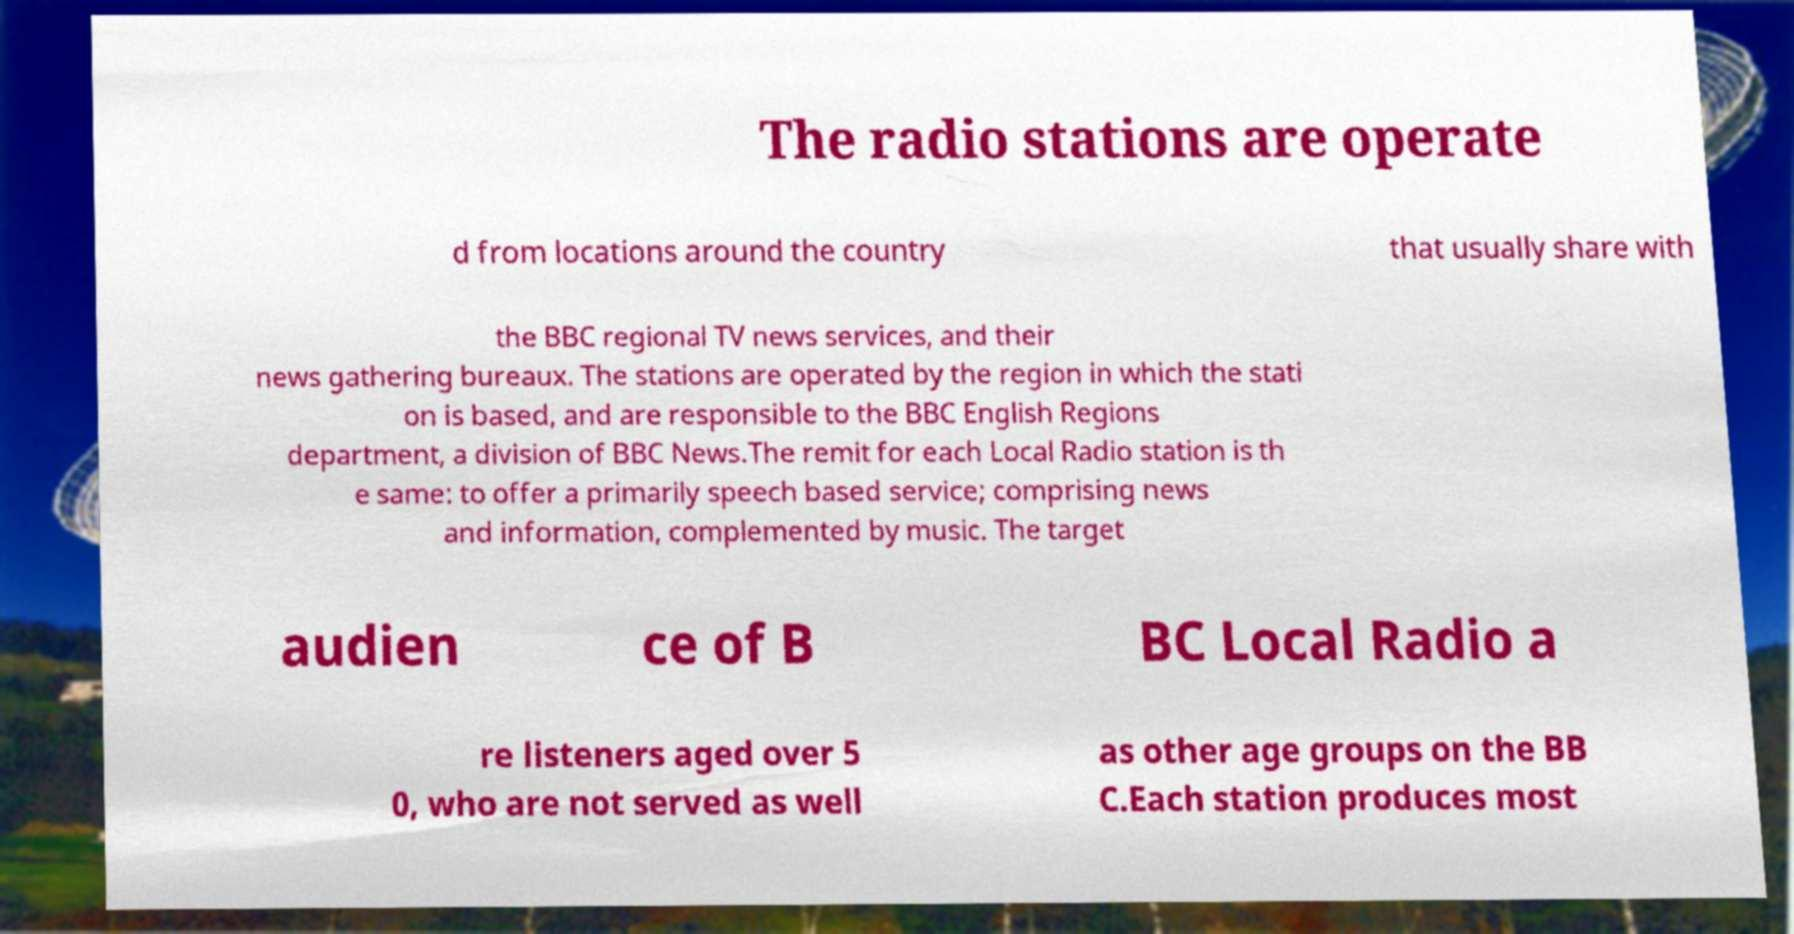What messages or text are displayed in this image? I need them in a readable, typed format. The radio stations are operate d from locations around the country that usually share with the BBC regional TV news services, and their news gathering bureaux. The stations are operated by the region in which the stati on is based, and are responsible to the BBC English Regions department, a division of BBC News.The remit for each Local Radio station is th e same: to offer a primarily speech based service; comprising news and information, complemented by music. The target audien ce of B BC Local Radio a re listeners aged over 5 0, who are not served as well as other age groups on the BB C.Each station produces most 